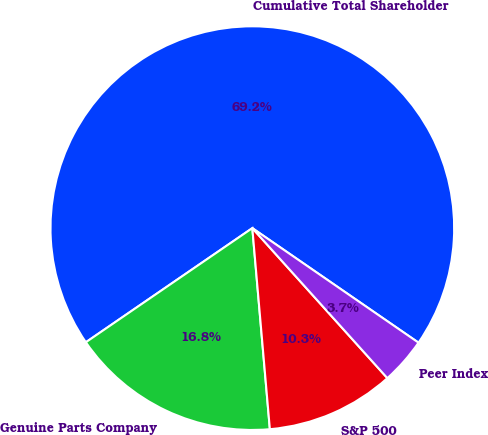Convert chart. <chart><loc_0><loc_0><loc_500><loc_500><pie_chart><fcel>Cumulative Total Shareholder<fcel>Genuine Parts Company<fcel>S&P 500<fcel>Peer Index<nl><fcel>69.17%<fcel>16.82%<fcel>10.28%<fcel>3.73%<nl></chart> 